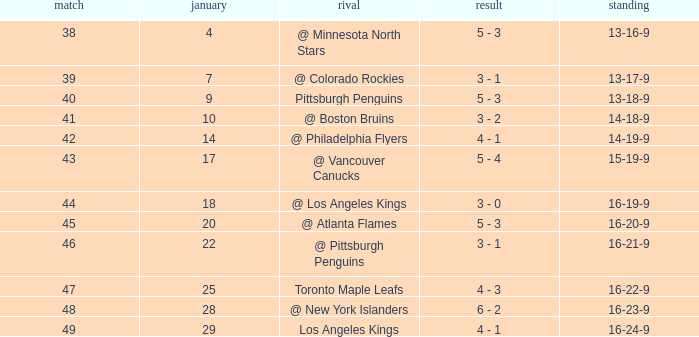What was the record after the game before Jan 7? 13-16-9. 